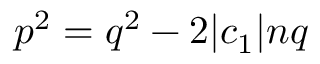Convert formula to latex. <formula><loc_0><loc_0><loc_500><loc_500>p ^ { 2 } = q ^ { 2 } - 2 | c _ { 1 } | n q</formula> 